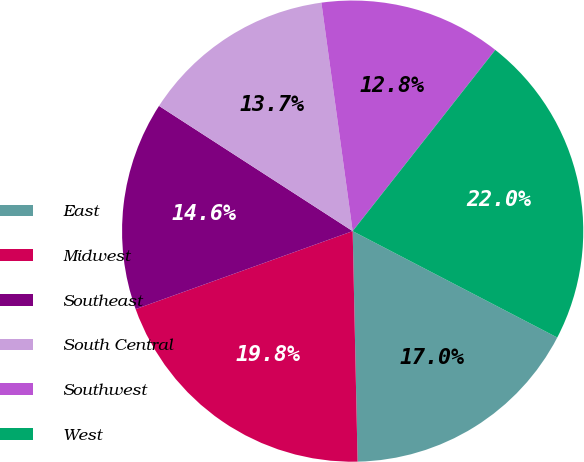<chart> <loc_0><loc_0><loc_500><loc_500><pie_chart><fcel>East<fcel>Midwest<fcel>Southeast<fcel>South Central<fcel>Southwest<fcel>West<nl><fcel>17.03%<fcel>19.85%<fcel>14.63%<fcel>13.7%<fcel>12.78%<fcel>22.02%<nl></chart> 